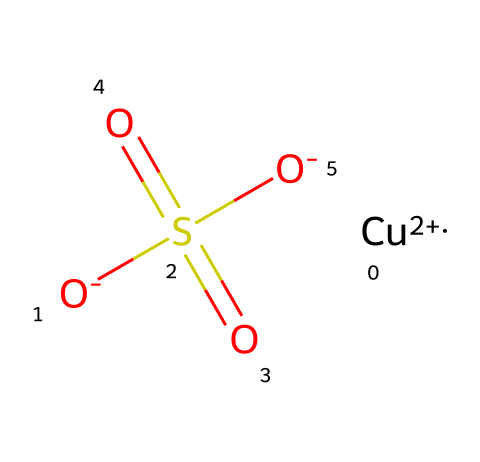What is the central metal atom in this chemical? The central metal atom is identified by its position and its oxidation state, which in this case corresponds to copper. The SMILES notation indicates the presence of "[Cu+2]", which signifies that copper is the core component.
Answer: copper How many oxygen atoms are present in this structure? To determine the number of oxygen atoms, one can count the occurrences of "O" in the SMILES representation. There are four instances when including the two "O-" and the two "O" in the sulfate group.
Answer: four What type of bond connects the copper atom to the sulfate structure? The bond between the copper atom and the sulfate group is ionic, as indicated by the charge difference—copper has a +2 charge while sulfate carries a negative charge. This results in an electrostatic attraction rather than the sharing of electrons, characteristic of covalent bonds.
Answer: ionic Is this compound soluble in water? Copper sulfate is known to be soluble in water, which can be inferred from its ionic nature, allowing the ions to dissociate and interact with water molecules. This quality is a common characteristic of many metal salts.
Answer: soluble What is the primary function of this chemical in wrestling mats? The primary function of copper sulfate in wrestling mats is as a fungicide. Its chemical properties allow it to inhibit the growth of mold and fungi, making it suitable for maintaining hygiene in the mats.
Answer: fungicide How does the presence of sulfur in this structure contribute to its function? Sulfur in the sulfate group contributes to the chemical's ability to disrupt cellular processes in fungi. It forms part of the sulfate ion, which affects biological systems by interfering with various metabolic pathways in fungal cells.
Answer: disrupts metabolic pathways 